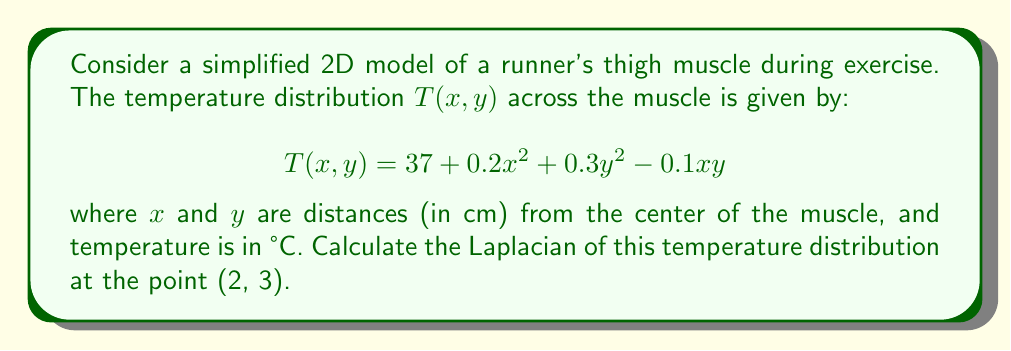Can you solve this math problem? To solve this problem, we'll follow these steps:

1) Recall that the Laplacian in 2D Cartesian coordinates is given by:

   $$\nabla^2T = \frac{\partial^2T}{\partial x^2} + \frac{\partial^2T}{\partial y^2}$$

2) First, let's find $\frac{\partial^2T}{\partial x^2}$:
   
   $\frac{\partial T}{\partial x} = 0.4x - 0.1y$
   $\frac{\partial^2T}{\partial x^2} = 0.4$

3) Now, let's find $\frac{\partial^2T}{\partial y^2}$:
   
   $\frac{\partial T}{\partial y} = 0.6y - 0.1x$
   $\frac{\partial^2T}{\partial y^2} = 0.6$

4) The Laplacian is the sum of these second partial derivatives:

   $$\nabla^2T = 0.4 + 0.6 = 1.0$$

5) This result is constant and doesn't depend on $x$ or $y$, so it's the same at all points, including (2, 3).

The Laplacian represents the rate at which the temperature deviates from the average of its neighboring values. A positive Laplacian indicates that the temperature at a point is generally higher than the average of its surroundings, which is consistent with heat generation in an exercising muscle.
Answer: $1.0$ °C/cm² 